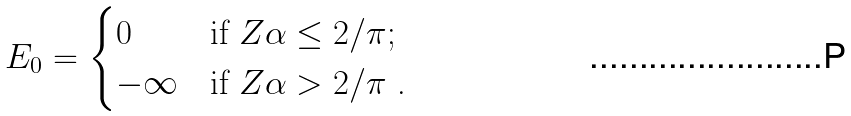<formula> <loc_0><loc_0><loc_500><loc_500>E _ { 0 } = \begin{cases} 0 & \text {if $Z\alpha \leq 2/\pi$;} \\ - \infty & \text {if $Z\alpha >2/\pi$ .} \end{cases}</formula> 